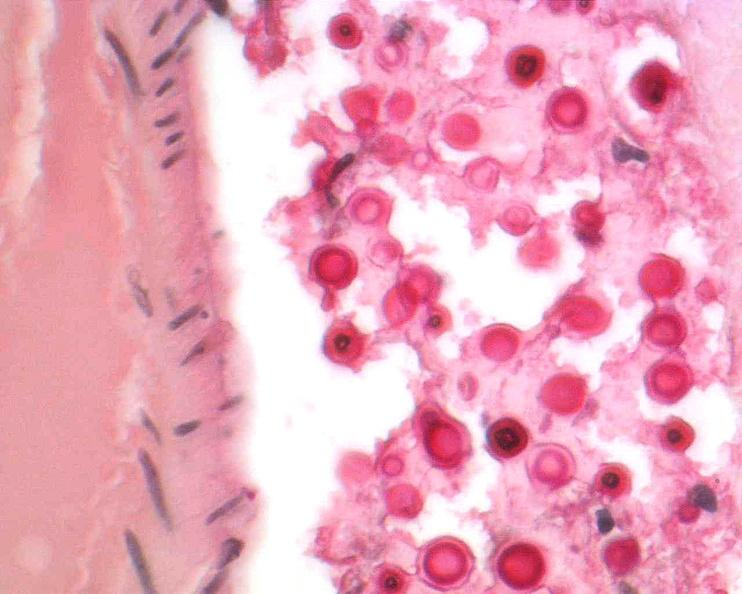s ameloblastoma present?
Answer the question using a single word or phrase. No 